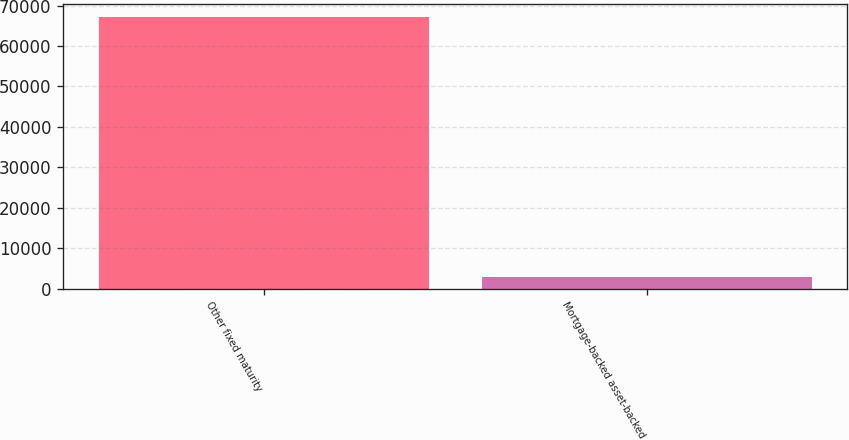<chart> <loc_0><loc_0><loc_500><loc_500><bar_chart><fcel>Other fixed maturity<fcel>Mortgage-backed asset-backed<nl><fcel>67076<fcel>2956<nl></chart> 